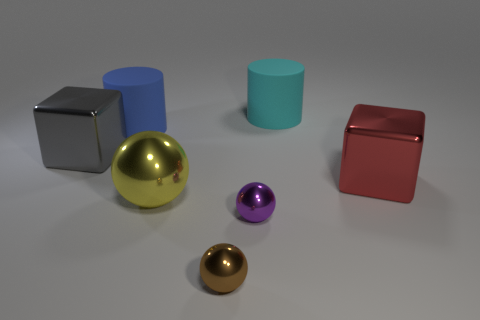Are there any purple things of the same size as the cyan cylinder?
Provide a succinct answer. No. There is a block that is on the left side of the metal ball that is to the left of the small brown metal ball; what is it made of?
Provide a succinct answer. Metal. What number of cylinders are the same color as the big ball?
Make the answer very short. 0. The big yellow object that is the same material as the big red thing is what shape?
Keep it short and to the point. Sphere. What is the size of the cube that is left of the blue matte cylinder?
Offer a terse response. Large. Is the number of big balls that are behind the gray object the same as the number of blocks that are to the left of the big yellow thing?
Provide a succinct answer. No. What color is the rubber thing in front of the matte object to the right of the tiny thing right of the brown sphere?
Your response must be concise. Blue. How many large shiny things are behind the yellow ball and on the left side of the red shiny object?
Provide a succinct answer. 1. What size is the other shiny object that is the same shape as the red metal object?
Keep it short and to the point. Large. There is a big cyan object; are there any rubber objects left of it?
Your answer should be very brief. Yes. 